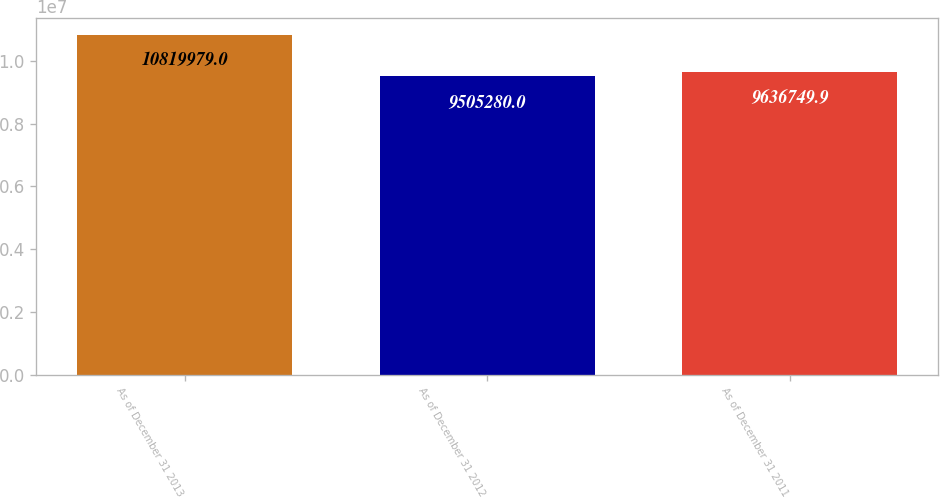Convert chart. <chart><loc_0><loc_0><loc_500><loc_500><bar_chart><fcel>As of December 31 2013<fcel>As of December 31 2012<fcel>As of December 31 2011<nl><fcel>1.082e+07<fcel>9.50528e+06<fcel>9.63675e+06<nl></chart> 